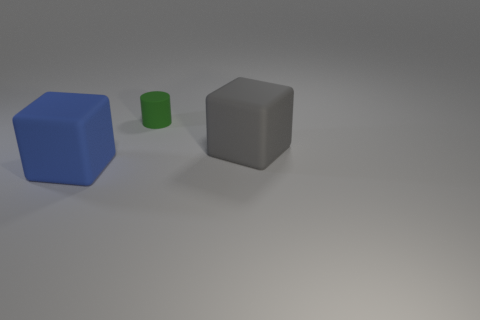Add 3 small rubber cylinders. How many objects exist? 6 Subtract all cylinders. How many objects are left? 2 Add 3 big gray rubber blocks. How many big gray rubber blocks are left? 4 Add 1 small green cylinders. How many small green cylinders exist? 2 Subtract 0 brown cylinders. How many objects are left? 3 Subtract all gray objects. Subtract all large blue matte objects. How many objects are left? 1 